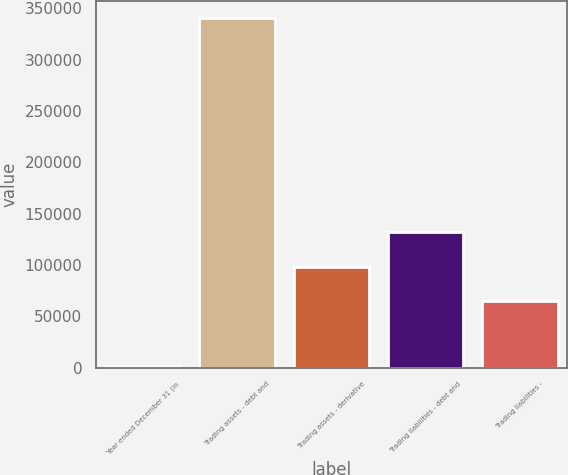Convert chart to OTSL. <chart><loc_0><loc_0><loc_500><loc_500><bar_chart><fcel>Year ended December 31 (in<fcel>Trading assets - debt and<fcel>Trading assets - derivative<fcel>Trading liabilities - debt and<fcel>Trading liabilities -<nl><fcel>2013<fcel>340449<fcel>98396.6<fcel>132240<fcel>64553<nl></chart> 